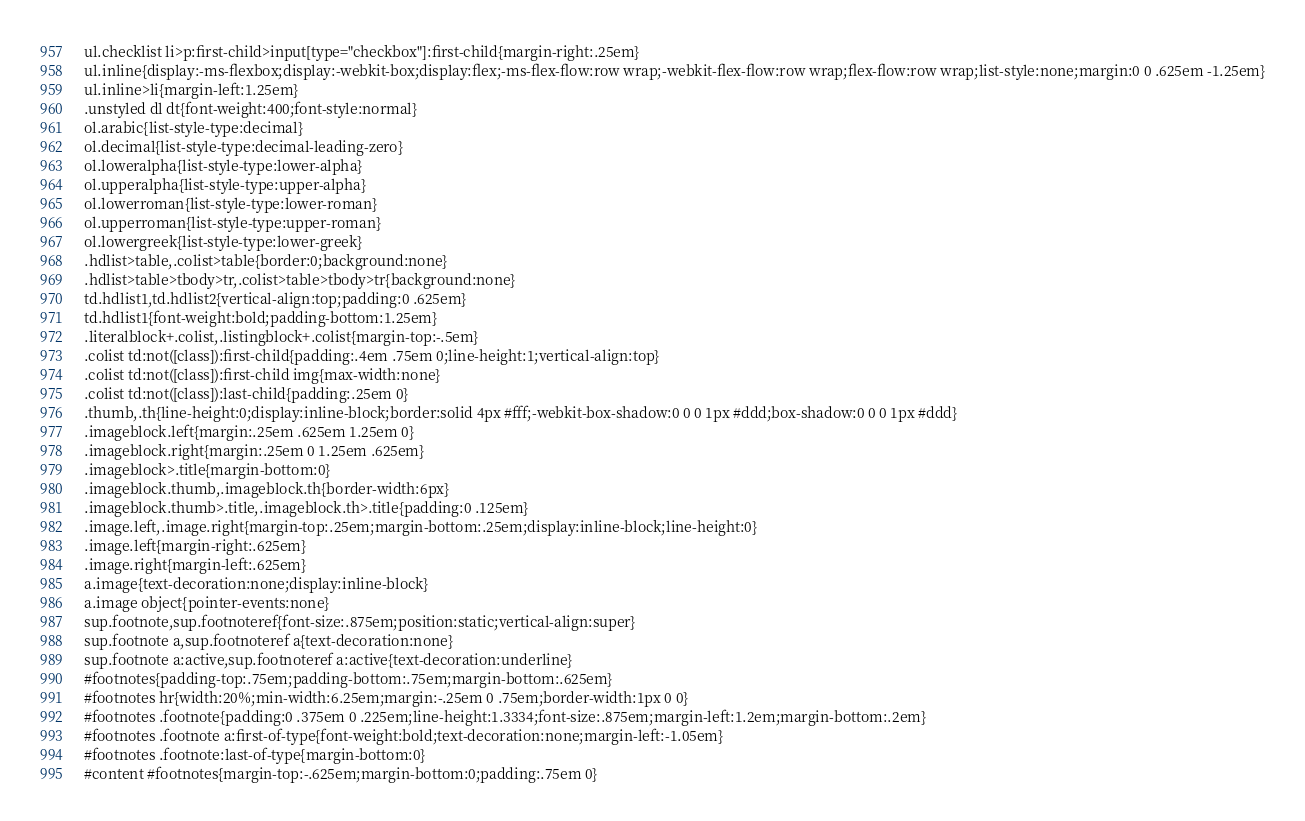<code> <loc_0><loc_0><loc_500><loc_500><_HTML_>ul.checklist li>p:first-child>input[type="checkbox"]:first-child{margin-right:.25em}
ul.inline{display:-ms-flexbox;display:-webkit-box;display:flex;-ms-flex-flow:row wrap;-webkit-flex-flow:row wrap;flex-flow:row wrap;list-style:none;margin:0 0 .625em -1.25em}
ul.inline>li{margin-left:1.25em}
.unstyled dl dt{font-weight:400;font-style:normal}
ol.arabic{list-style-type:decimal}
ol.decimal{list-style-type:decimal-leading-zero}
ol.loweralpha{list-style-type:lower-alpha}
ol.upperalpha{list-style-type:upper-alpha}
ol.lowerroman{list-style-type:lower-roman}
ol.upperroman{list-style-type:upper-roman}
ol.lowergreek{list-style-type:lower-greek}
.hdlist>table,.colist>table{border:0;background:none}
.hdlist>table>tbody>tr,.colist>table>tbody>tr{background:none}
td.hdlist1,td.hdlist2{vertical-align:top;padding:0 .625em}
td.hdlist1{font-weight:bold;padding-bottom:1.25em}
.literalblock+.colist,.listingblock+.colist{margin-top:-.5em}
.colist td:not([class]):first-child{padding:.4em .75em 0;line-height:1;vertical-align:top}
.colist td:not([class]):first-child img{max-width:none}
.colist td:not([class]):last-child{padding:.25em 0}
.thumb,.th{line-height:0;display:inline-block;border:solid 4px #fff;-webkit-box-shadow:0 0 0 1px #ddd;box-shadow:0 0 0 1px #ddd}
.imageblock.left{margin:.25em .625em 1.25em 0}
.imageblock.right{margin:.25em 0 1.25em .625em}
.imageblock>.title{margin-bottom:0}
.imageblock.thumb,.imageblock.th{border-width:6px}
.imageblock.thumb>.title,.imageblock.th>.title{padding:0 .125em}
.image.left,.image.right{margin-top:.25em;margin-bottom:.25em;display:inline-block;line-height:0}
.image.left{margin-right:.625em}
.image.right{margin-left:.625em}
a.image{text-decoration:none;display:inline-block}
a.image object{pointer-events:none}
sup.footnote,sup.footnoteref{font-size:.875em;position:static;vertical-align:super}
sup.footnote a,sup.footnoteref a{text-decoration:none}
sup.footnote a:active,sup.footnoteref a:active{text-decoration:underline}
#footnotes{padding-top:.75em;padding-bottom:.75em;margin-bottom:.625em}
#footnotes hr{width:20%;min-width:6.25em;margin:-.25em 0 .75em;border-width:1px 0 0}
#footnotes .footnote{padding:0 .375em 0 .225em;line-height:1.3334;font-size:.875em;margin-left:1.2em;margin-bottom:.2em}
#footnotes .footnote a:first-of-type{font-weight:bold;text-decoration:none;margin-left:-1.05em}
#footnotes .footnote:last-of-type{margin-bottom:0}
#content #footnotes{margin-top:-.625em;margin-bottom:0;padding:.75em 0}</code> 